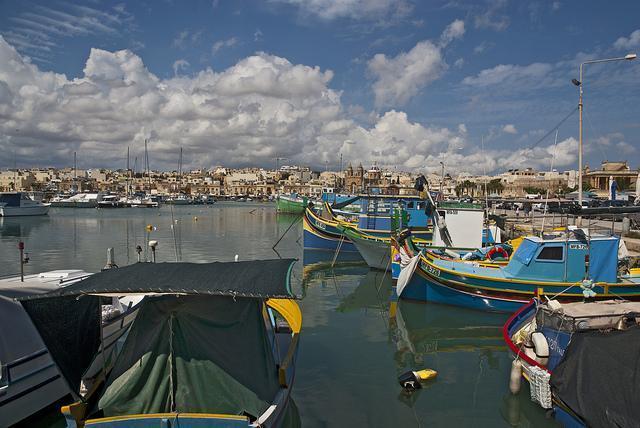How many boats are in the picture?
Give a very brief answer. 4. 